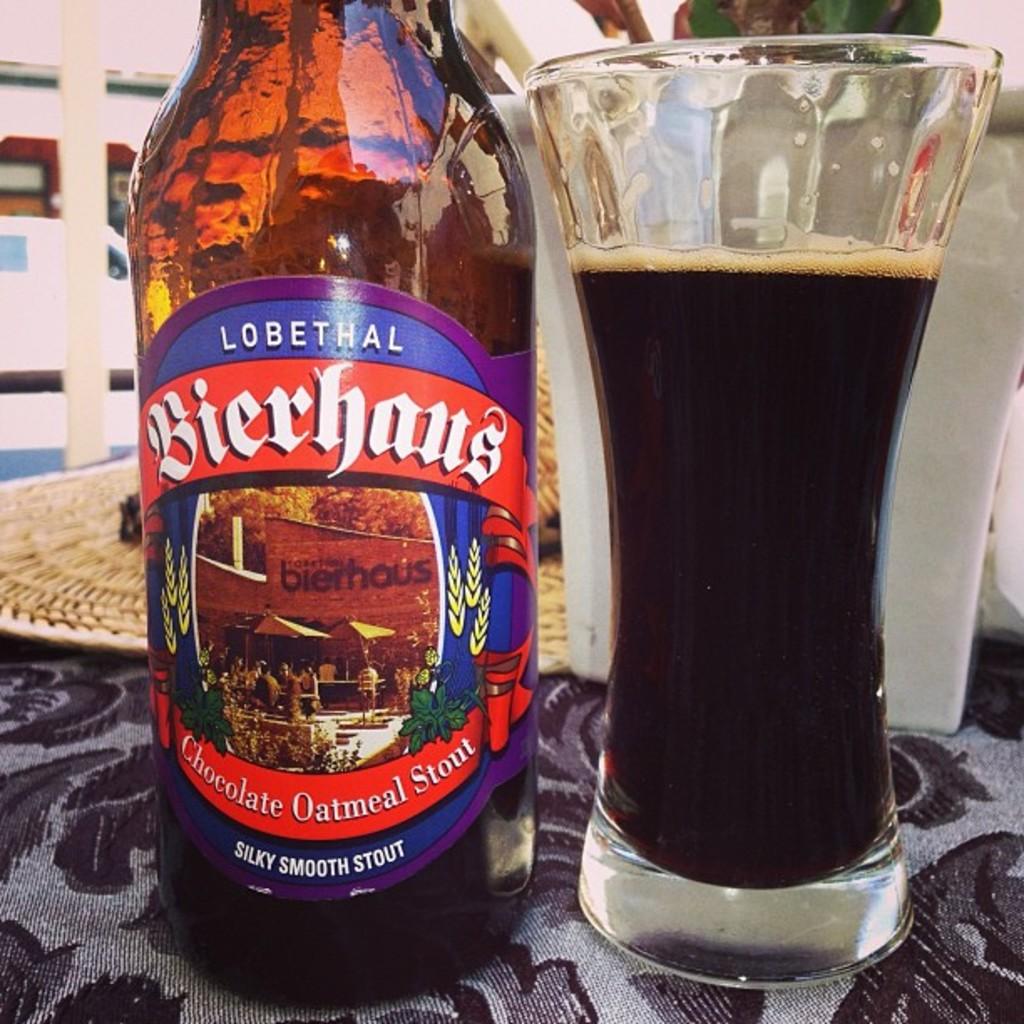What brand of beer is this?
Make the answer very short. Bierhaus. 